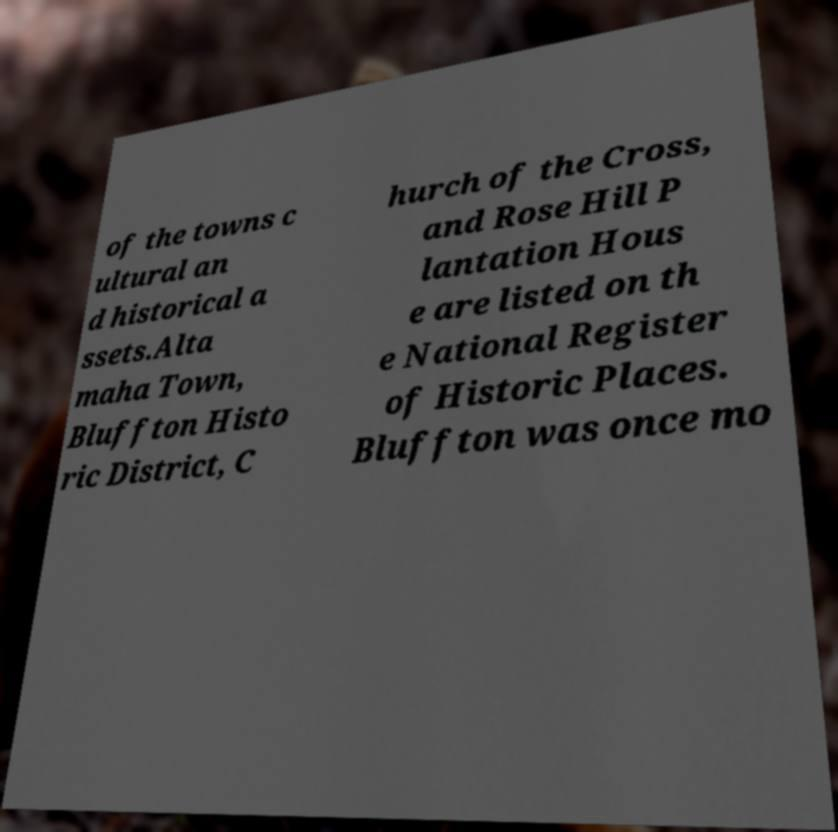Please read and relay the text visible in this image. What does it say? of the towns c ultural an d historical a ssets.Alta maha Town, Bluffton Histo ric District, C hurch of the Cross, and Rose Hill P lantation Hous e are listed on th e National Register of Historic Places. Bluffton was once mo 